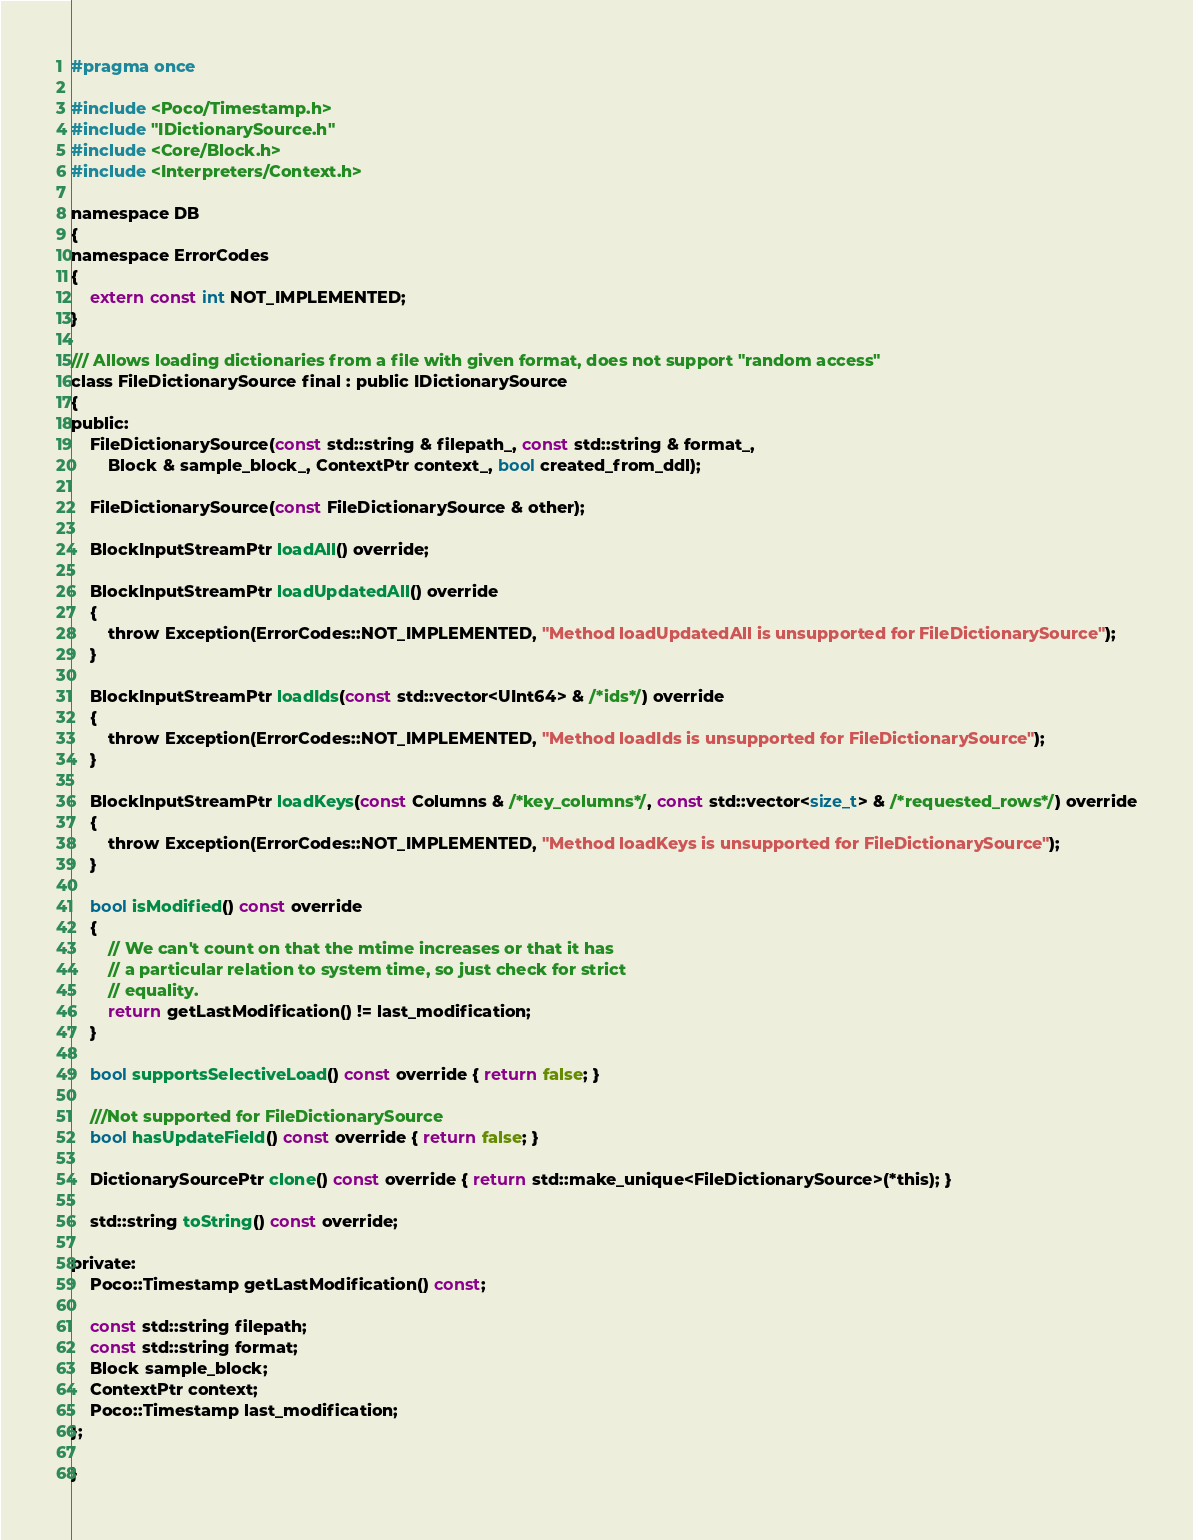<code> <loc_0><loc_0><loc_500><loc_500><_C_>#pragma once

#include <Poco/Timestamp.h>
#include "IDictionarySource.h"
#include <Core/Block.h>
#include <Interpreters/Context.h>

namespace DB
{
namespace ErrorCodes
{
    extern const int NOT_IMPLEMENTED;
}

/// Allows loading dictionaries from a file with given format, does not support "random access"
class FileDictionarySource final : public IDictionarySource
{
public:
    FileDictionarySource(const std::string & filepath_, const std::string & format_,
        Block & sample_block_, ContextPtr context_, bool created_from_ddl);

    FileDictionarySource(const FileDictionarySource & other);

    BlockInputStreamPtr loadAll() override;

    BlockInputStreamPtr loadUpdatedAll() override
    {
        throw Exception(ErrorCodes::NOT_IMPLEMENTED, "Method loadUpdatedAll is unsupported for FileDictionarySource");
    }

    BlockInputStreamPtr loadIds(const std::vector<UInt64> & /*ids*/) override
    {
        throw Exception(ErrorCodes::NOT_IMPLEMENTED, "Method loadIds is unsupported for FileDictionarySource");
    }

    BlockInputStreamPtr loadKeys(const Columns & /*key_columns*/, const std::vector<size_t> & /*requested_rows*/) override
    {
        throw Exception(ErrorCodes::NOT_IMPLEMENTED, "Method loadKeys is unsupported for FileDictionarySource");
    }

    bool isModified() const override
    {
        // We can't count on that the mtime increases or that it has
        // a particular relation to system time, so just check for strict
        // equality.
        return getLastModification() != last_modification;
    }

    bool supportsSelectiveLoad() const override { return false; }

    ///Not supported for FileDictionarySource
    bool hasUpdateField() const override { return false; }

    DictionarySourcePtr clone() const override { return std::make_unique<FileDictionarySource>(*this); }

    std::string toString() const override;

private:
    Poco::Timestamp getLastModification() const;

    const std::string filepath;
    const std::string format;
    Block sample_block;
    ContextPtr context;
    Poco::Timestamp last_modification;
};

}
</code> 